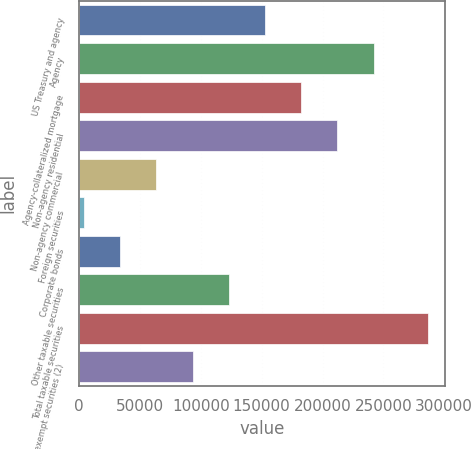<chart> <loc_0><loc_0><loc_500><loc_500><bar_chart><fcel>US Treasury and agency<fcel>Agency<fcel>Agency-collateralized mortgage<fcel>Non-agency residential<fcel>Non-agency commercial<fcel>Foreign securities<fcel>Corporate bonds<fcel>Other taxable securities<fcel>Total taxable securities<fcel>Tax-exempt securities (2)<nl><fcel>152749<fcel>242060<fcel>182519<fcel>212290<fcel>63437.8<fcel>3897<fcel>33667.4<fcel>122979<fcel>286395<fcel>93208.2<nl></chart> 